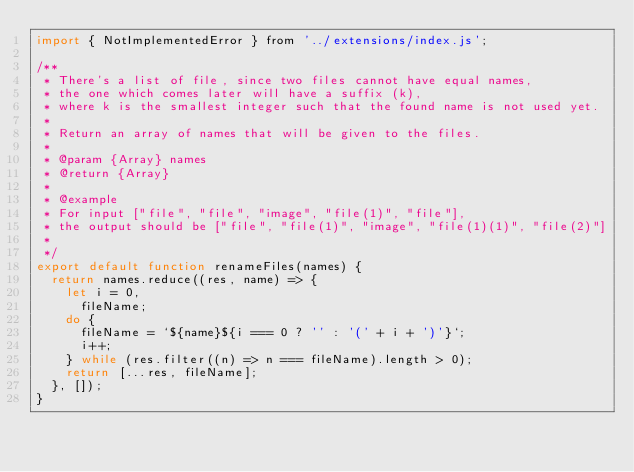Convert code to text. <code><loc_0><loc_0><loc_500><loc_500><_JavaScript_>import { NotImplementedError } from '../extensions/index.js';

/**
 * There's a list of file, since two files cannot have equal names,
 * the one which comes later will have a suffix (k),
 * where k is the smallest integer such that the found name is not used yet.
 *
 * Return an array of names that will be given to the files.
 *
 * @param {Array} names
 * @return {Array}
 *
 * @example
 * For input ["file", "file", "image", "file(1)", "file"],
 * the output should be ["file", "file(1)", "image", "file(1)(1)", "file(2)"]
 *
 */
export default function renameFiles(names) {
  return names.reduce((res, name) => {
    let i = 0,
      fileName;
    do {
      fileName = `${name}${i === 0 ? '' : '(' + i + ')'}`;
      i++;
    } while (res.filter((n) => n === fileName).length > 0);
    return [...res, fileName];
  }, []);
}
</code> 